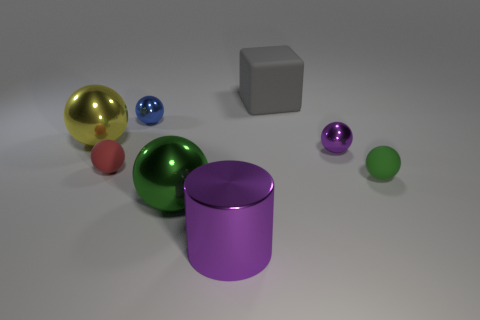Subtract all small red balls. How many balls are left? 5 Subtract 1 balls. How many balls are left? 5 Subtract all yellow spheres. How many spheres are left? 5 Add 2 rubber spheres. How many objects exist? 10 Subtract all yellow balls. Subtract all yellow cylinders. How many balls are left? 5 Add 5 shiny cylinders. How many shiny cylinders are left? 6 Add 8 rubber balls. How many rubber balls exist? 10 Subtract 0 gray spheres. How many objects are left? 8 Subtract all cylinders. How many objects are left? 7 Subtract all brown cylinders. How many red balls are left? 1 